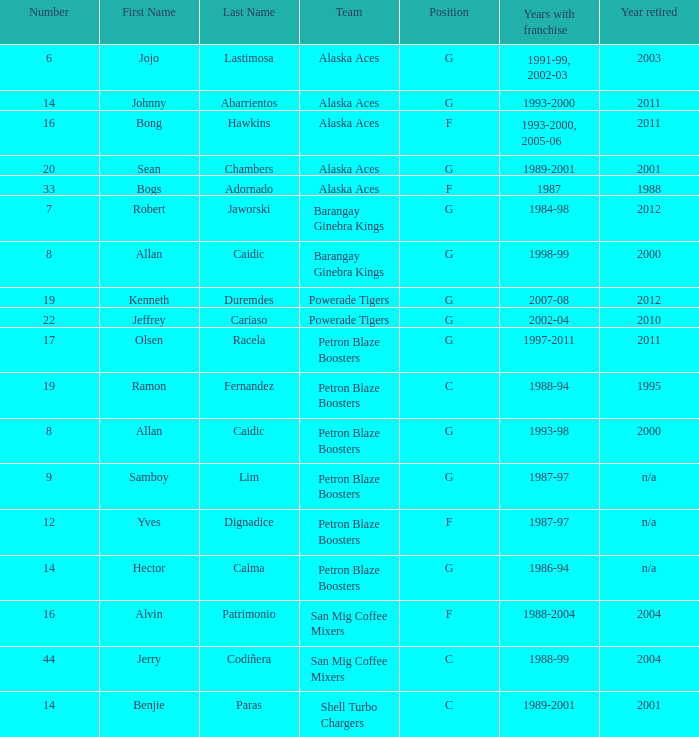How many years did the team in slot number 9 have a franchise? 1987-97. 